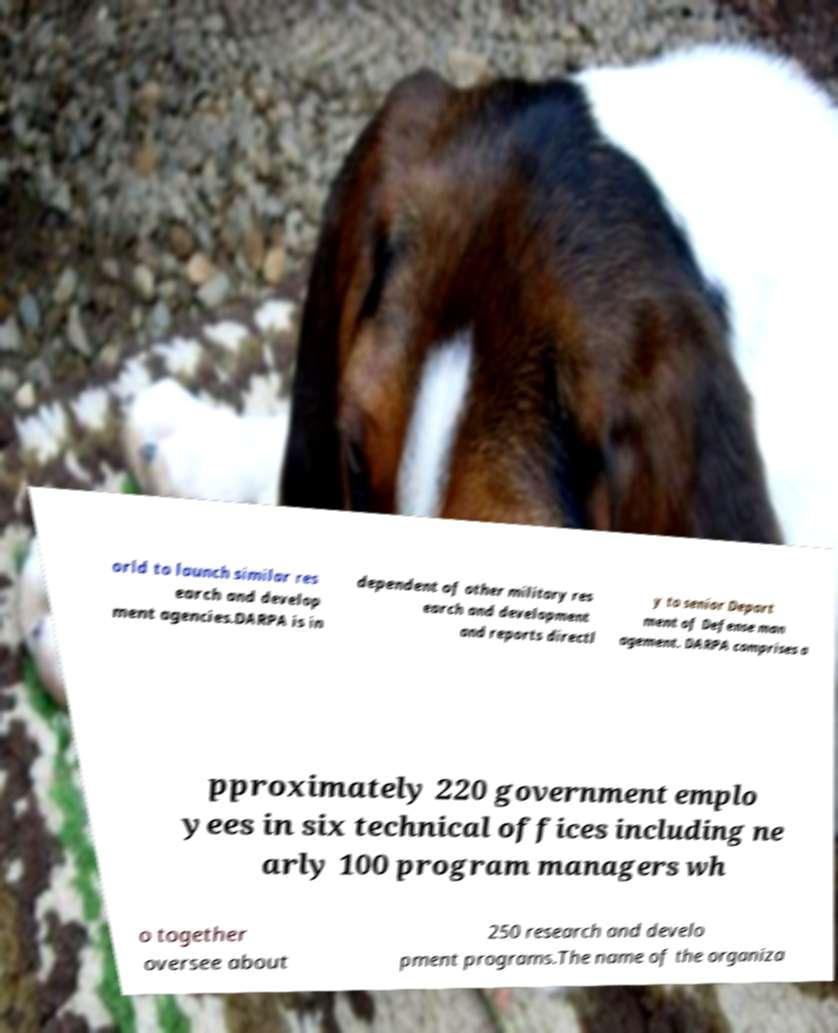Can you read and provide the text displayed in the image?This photo seems to have some interesting text. Can you extract and type it out for me? orld to launch similar res earch and develop ment agencies.DARPA is in dependent of other military res earch and development and reports directl y to senior Depart ment of Defense man agement. DARPA comprises a pproximately 220 government emplo yees in six technical offices including ne arly 100 program managers wh o together oversee about 250 research and develo pment programs.The name of the organiza 